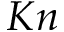<formula> <loc_0><loc_0><loc_500><loc_500>K n</formula> 